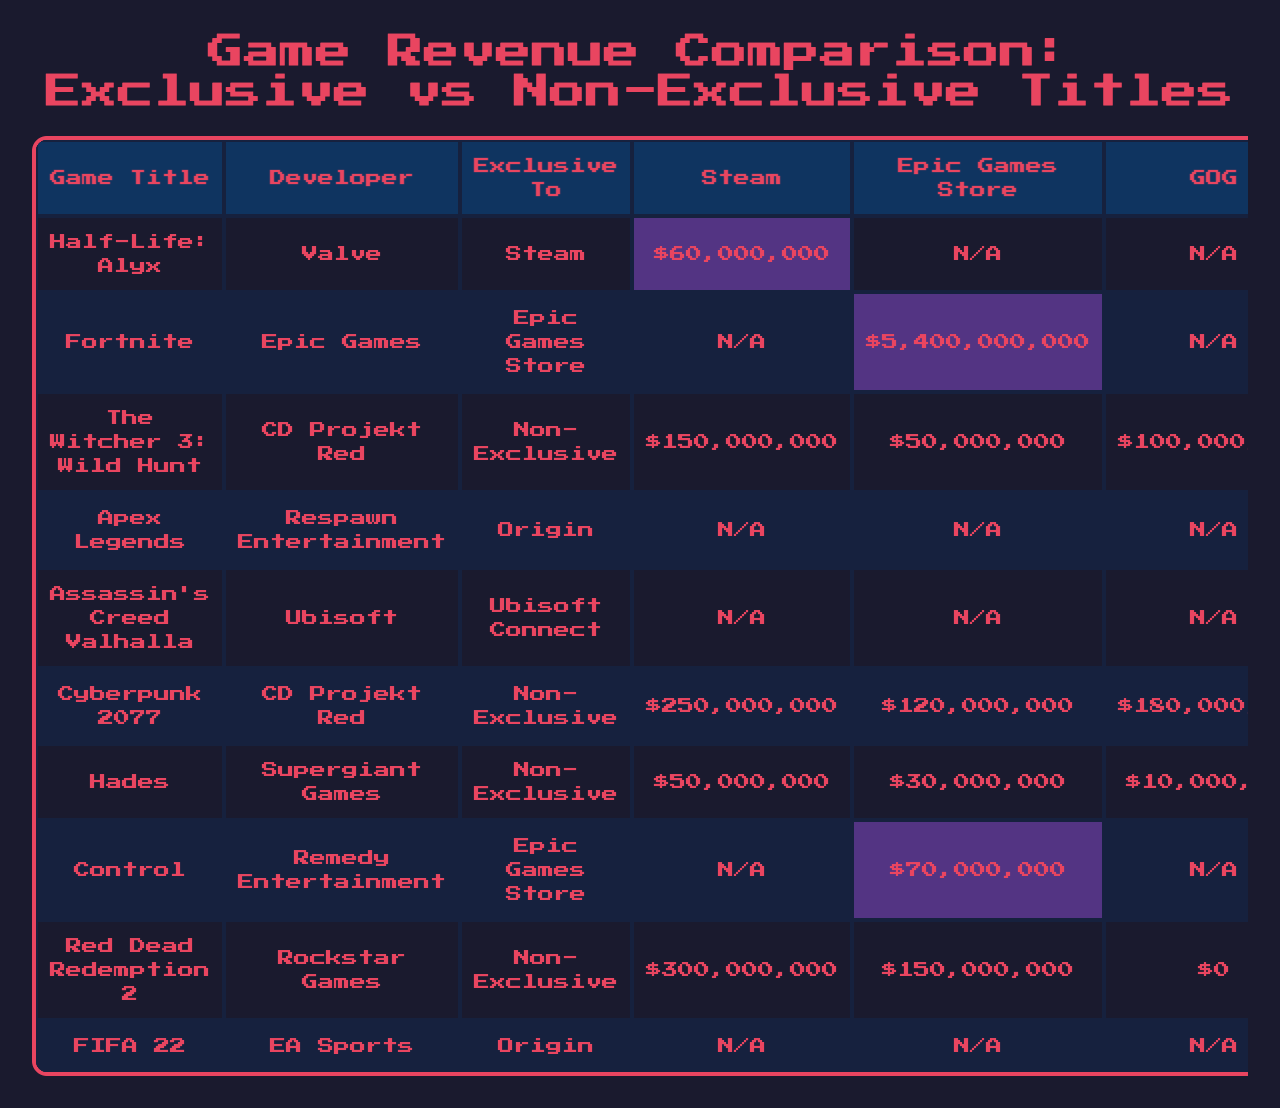What is the revenue for "Half-Life: Alyx"? The table shows that "Half-Life: Alyx," which is exclusive to Steam, generated a revenue of $60,000,000.
Answer: $60,000,000 How much revenue did "Fortnite" earn on the Epic Games Store? The revenue for "Fortnite," which is exclusive to the Epic Games Store, is listed as $5,400,000,000.
Answer: $5,400,000,000 Which game generated the highest revenue overall? By looking at the revenue figures, "Fortnite" has the highest revenue at $5,400,000,000, making it the top game listed.
Answer: "Fortnite" Is "Control" an exclusive title? "Control" is marked as exclusive to the Epic Games Store, which confirms that it is indeed an exclusive title.
Answer: Yes Which store earned the most from non-exclusive titles? To find this, we sum non-exclusive revenues from each store: Steam ($150,000,000 + $250,000,000 + $50,000,000 = $450,000,000), Epic Games Store ($50,000,000 + $120,000,000 + $30,000,000 + $150,000,000 = $350,000,000), and GOG ($100,000,000 + $180,000,000 + $10,000,000 = $290,000,000). The store with the highest total is Steam at $450,000,000.
Answer: Steam What is the total revenue generated by exclusive titles across all stores? The total revenue can be calculated by adding individual exclusive revenues: Steam ($60,000,000) + Epic Games Store ($5,400,000,000) + Origin ($2,000,000,000) + Ubisoft Connect ($800,000,000) = $8,260,000,000.
Answer: $8,260,000,000 How does the revenue from "Cyberpunk 2077" on Steam compare to "The Witcher 3: Wild Hunt" on Epic Games Store? "Cyberpunk 2077" earned $250,000,000 on Steam while "The Witcher 3: Wild Hunt" earned $50,000,000 on Epic Games Store. Comparing the two, "Cyberpunk 2077" earned $200,000,000 more than "The Witcher 3".
Answer: $200,000,000 more Which exclusive title has the lowest revenue? On the table, the exclusive title with the lowest revenue is "Control," which earned $70,000,000 on the Epic Games Store.
Answer: "Control" If the total exclusive revenue from Epic Games Store is $5,470,000,000, what is the exclusive revenue from other stores? Subtracting Epic Games Store exclusive revenue from the total exclusive revenue ($8,260,000,000 - $5,470,000,000) results in $2,790,000,000 coming from other stores.
Answer: $2,790,000,000 Do any non-exclusive titles earn more than $300 million in total? Yes, "The Witcher 3: Wild Hunt" and "Red Dead Redemption 2" combined revenues exceed $300 million ($150,000,000 + $250,000,000 + $300,000,000 + $150,000,000 + 100,000,000 = $400,000,000).
Answer: Yes What percentage of the revenue from "FIFA 22" is represented by the revenue from non-exclusive titles on Steam? "FIFA 22" earned $1,500,000,000. Non-exclusive titles on Steam earned $400,000,000 total. The percentage can be calculated as ($400,000,000 / $1,500,000,000) * 100 = 26.67%.
Answer: 26.67% 